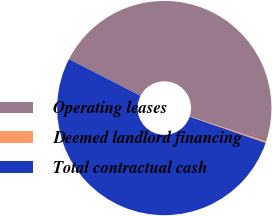Convert chart to OTSL. <chart><loc_0><loc_0><loc_500><loc_500><pie_chart><fcel>Operating leases<fcel>Deemed landlord financing<fcel>Total contractual cash<nl><fcel>47.52%<fcel>0.21%<fcel>52.27%<nl></chart> 